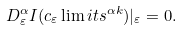Convert formula to latex. <formula><loc_0><loc_0><loc_500><loc_500>D ^ { \alpha } _ { \varepsilon } I ( { { c _ { \varepsilon } } \lim i t s ^ { \alpha k } } ) | _ { \varepsilon } = 0 .</formula> 